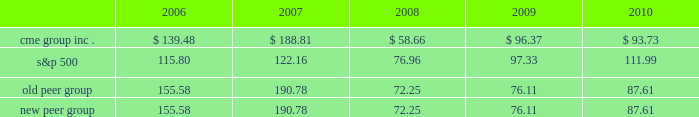Performance graph the following graph compares the cumulative five-year total return provided shareholders on our class a common stock relative to the cumulative total returns of the s&p 500 index and two customized peer groups .
The old peer group includes intercontinentalexchange , inc. , nyse euronext and the nasdaq omx group inc .
The new peer group is the same as the old peer group with the addition of cboe holdings , inc .
Which completed its initial public offering in june 2010 .
An investment of $ 100 ( with reinvestment of all dividends ) is assumed to have been made in our class a common stock , in the peer groups and the s&p 500 index on december 31 , 2005 and its relative performance is tracked through december 31 , 2010 .
Comparison of 5 year cumulative total return* among cme group inc. , the s&p 500 index , an old peer group and a new peer group 12/05 12/06 12/07 12/08 12/09 12/10 cme group inc .
S&p 500 old peer group *$ 100 invested on 12/31/05 in stock or index , including reinvestment of dividends .
Fiscal year ending december 31 .
Copyright a9 2011 s&p , a division of the mcgraw-hill companies inc .
All rights reserved .
New peer group the stock price performance included in this graph is not necessarily indicative of future stock price performance .

Considering the year 2006 , what is the percentual fluctuation of the return provided by s&p 500 and the one provided by old peer group? 
Rationale: its the difference between the return's percentage of both s&p 500 ( 15.8% ) and old peer group ( 55.58% )
Computations: ((155.58 - 100) - (115.80 - 100))
Answer: 39.78. 